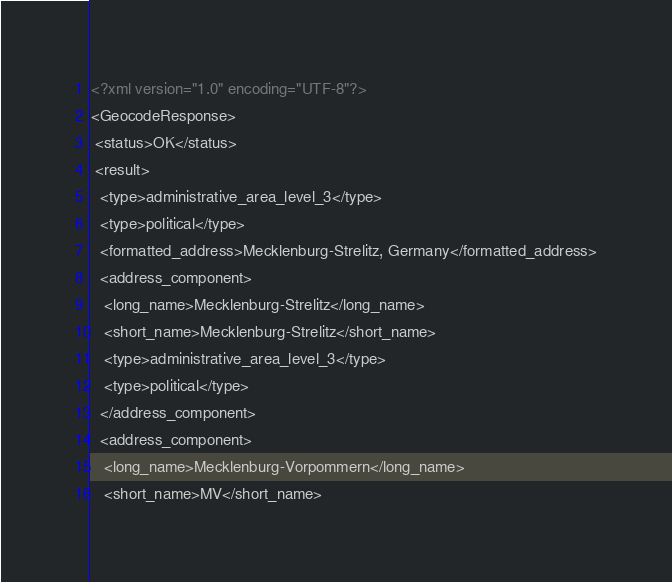<code> <loc_0><loc_0><loc_500><loc_500><_XML_><?xml version="1.0" encoding="UTF-8"?>
<GeocodeResponse>
 <status>OK</status>
 <result>
  <type>administrative_area_level_3</type>
  <type>political</type>
  <formatted_address>Mecklenburg-Strelitz, Germany</formatted_address>
  <address_component>
   <long_name>Mecklenburg-Strelitz</long_name>
   <short_name>Mecklenburg-Strelitz</short_name>
   <type>administrative_area_level_3</type>
   <type>political</type>
  </address_component>
  <address_component>
   <long_name>Mecklenburg-Vorpommern</long_name>
   <short_name>MV</short_name></code> 